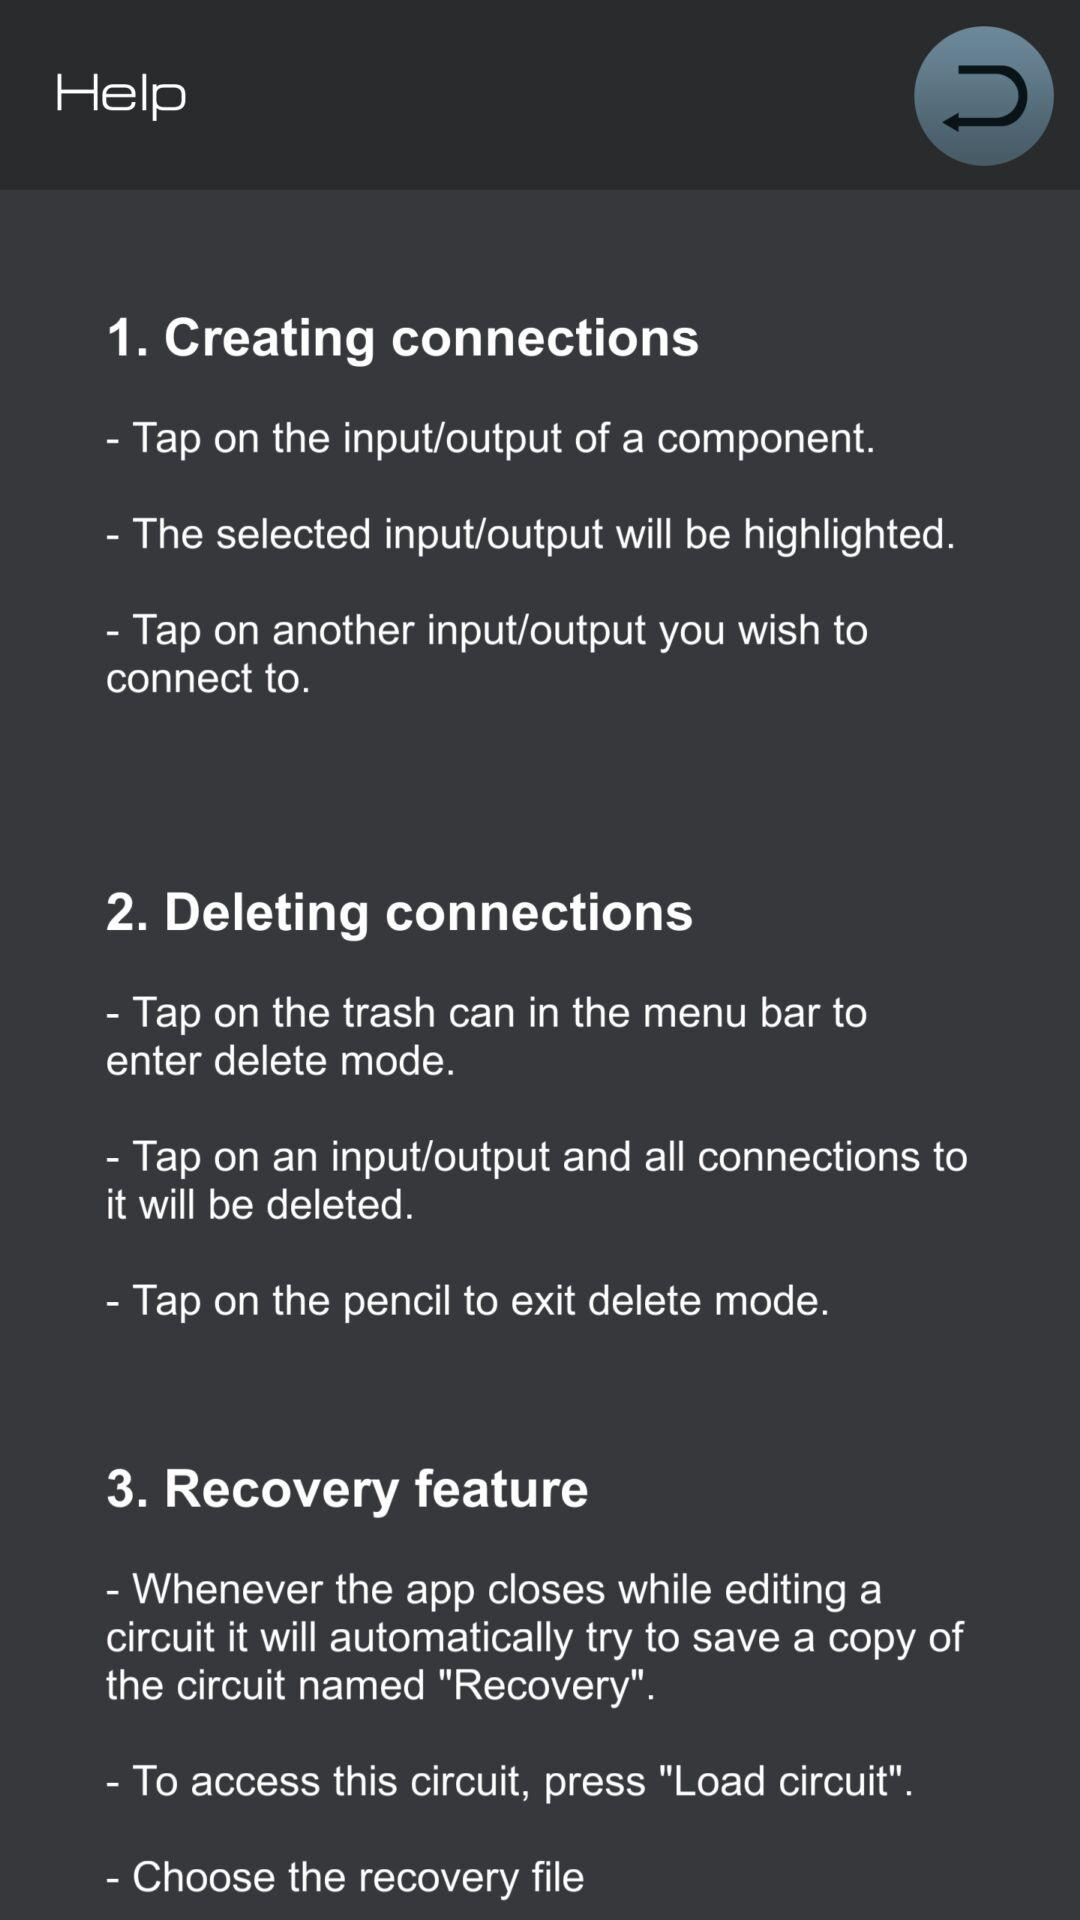How many steps are there in deleting a connection?
Answer the question using a single word or phrase. 3 